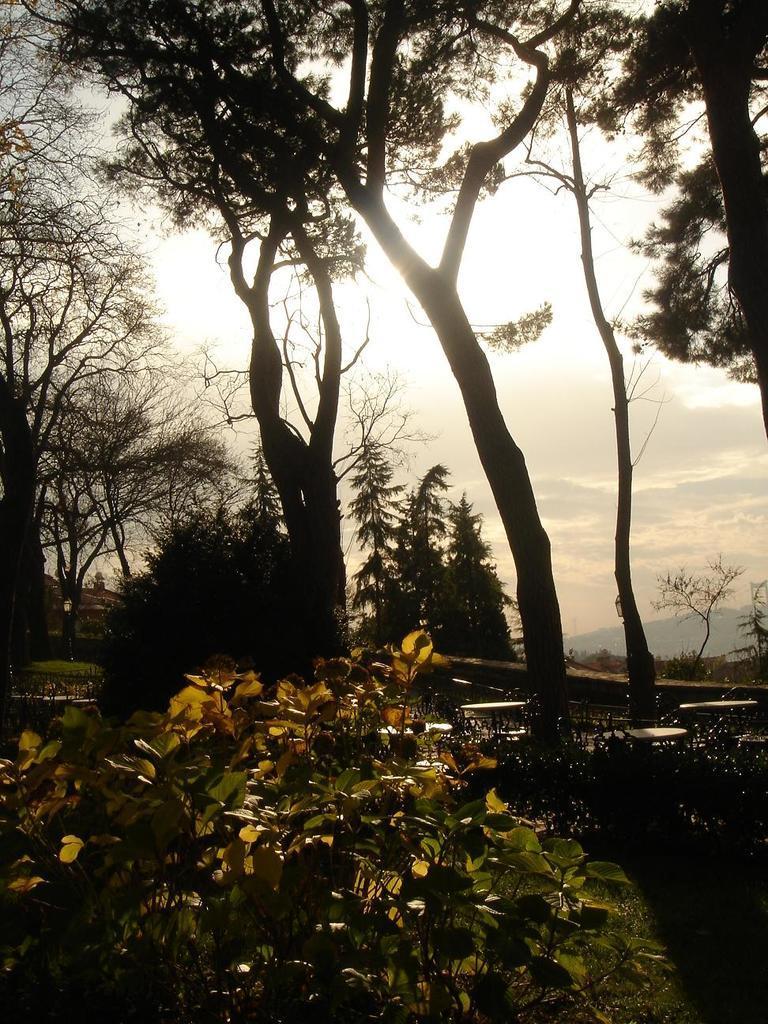Can you describe this image briefly? In this image there are plants and trees on the ground. At the top there is the sky. In the background there are mountains. 